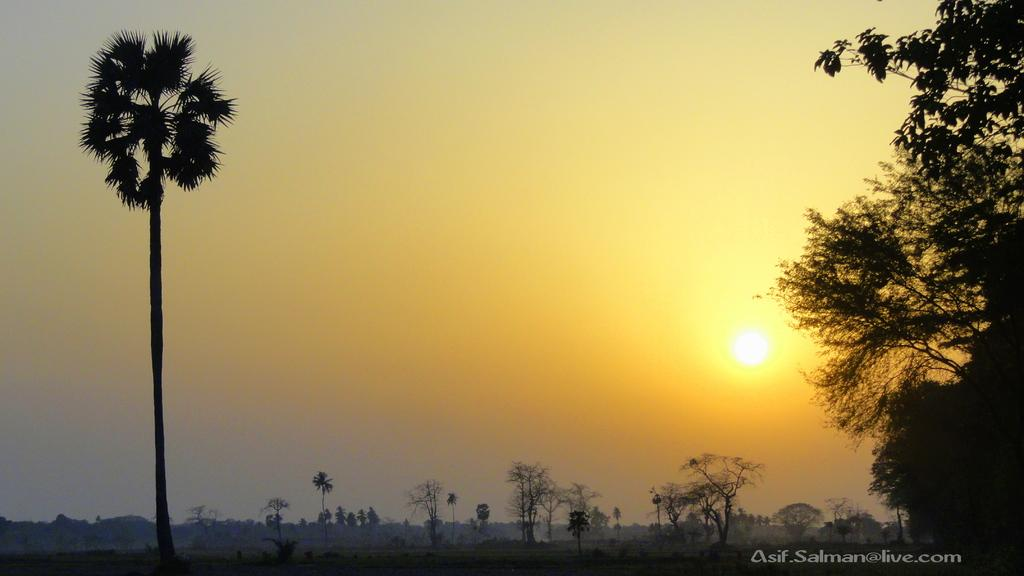What type of vegetation can be seen on the right side of the image? There are trees on the right side of the image. What is present on the left side of the image? There is a tree on the left side of the image. What can be seen in the background of the image? There are trees and the sun visible in the background of the image. What else is visible in the background of the image? The sky is visible in the background of the image. What type of lunch is being served in the image? There is no lunch present in the image; it features trees and a sunny sky. What memory is being triggered by the image? The image does not depict a specific memory; it is a scene of trees and the sky. 